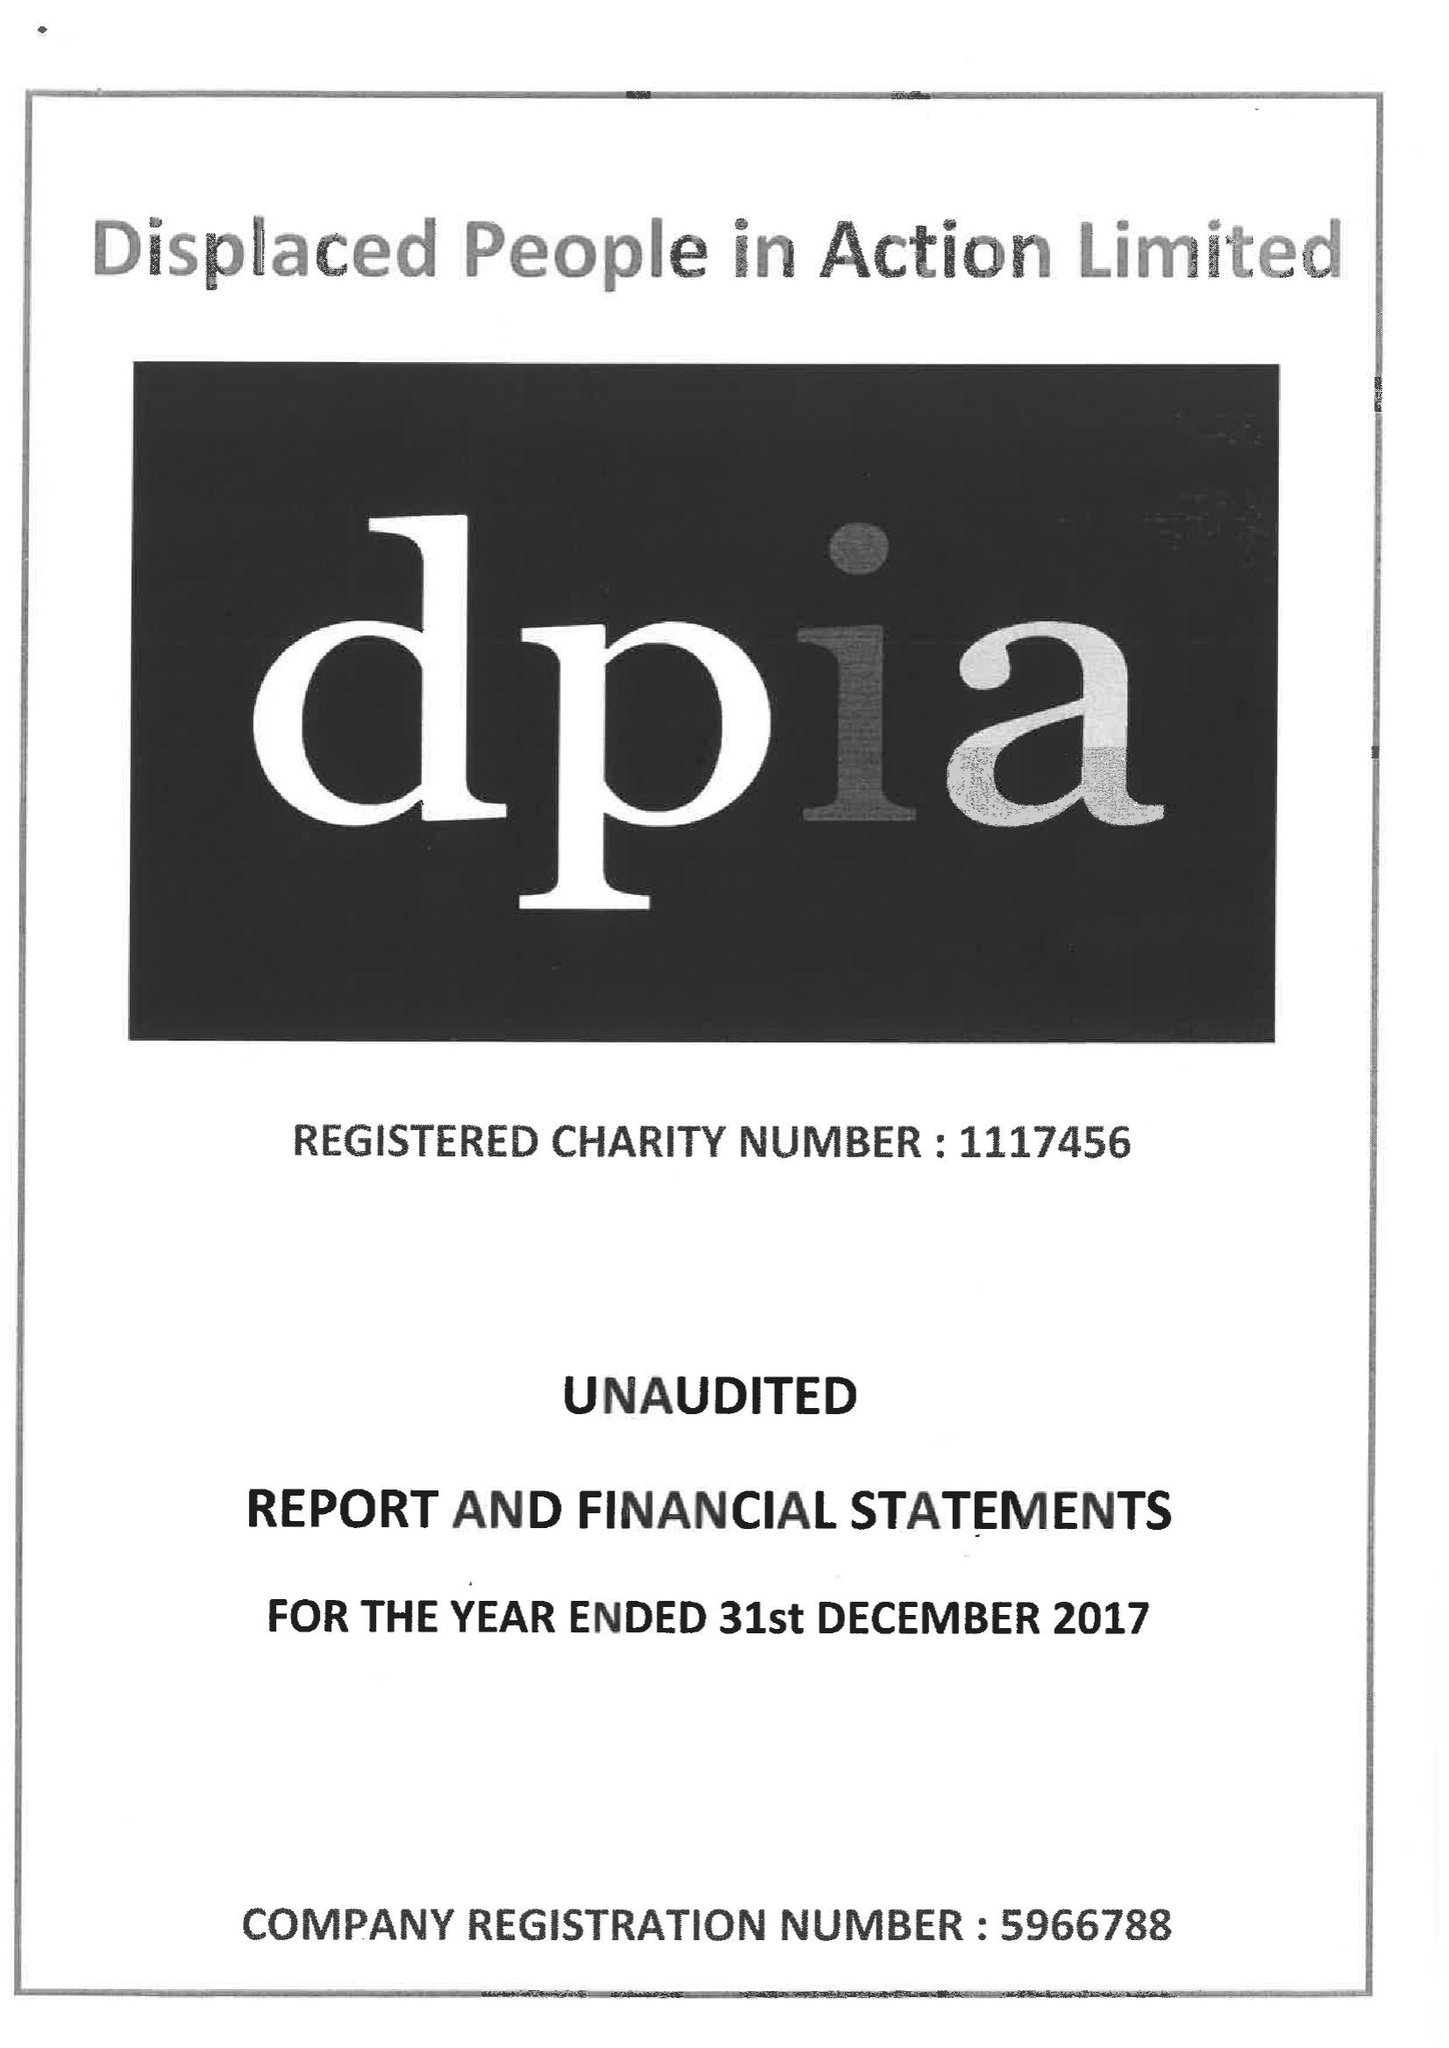What is the value for the address__post_town?
Answer the question using a single word or phrase. CARDIFF 